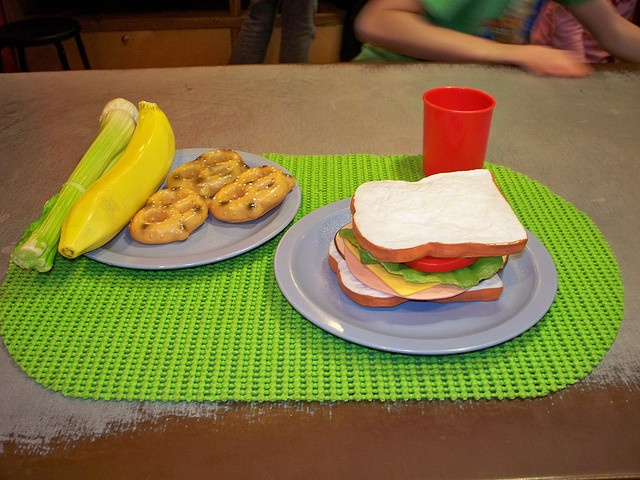Describe the objects in this image and their specific colors. I can see dining table in black, maroon, gray, and olive tones, sandwich in black, ivory, brown, tan, and olive tones, people in black, maroon, and brown tones, banana in black, gold, and olive tones, and cup in black, brown, and olive tones in this image. 